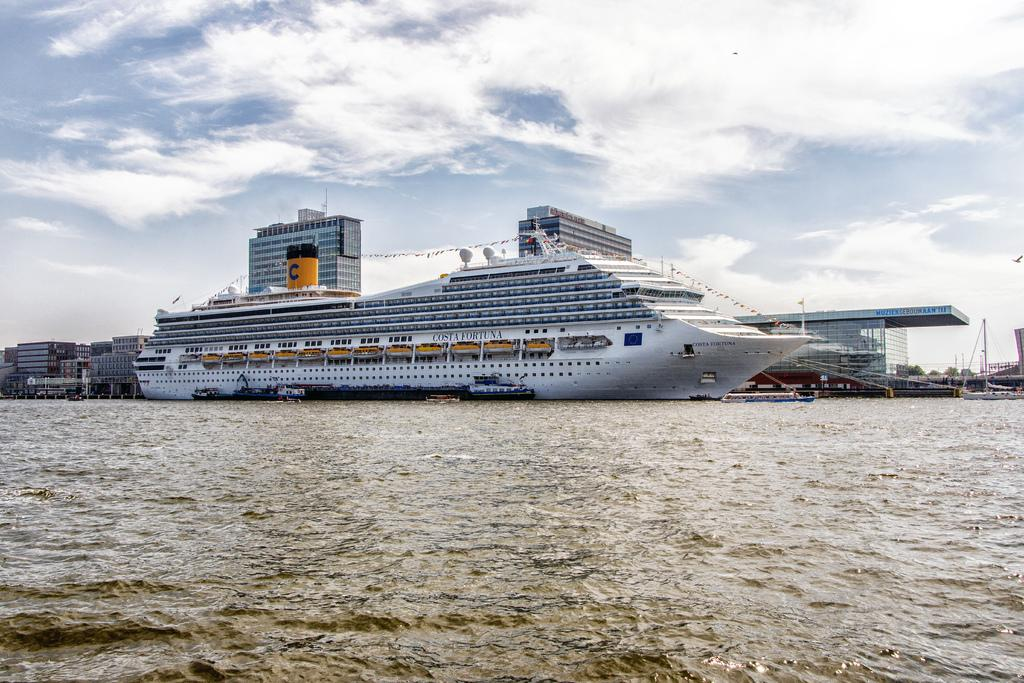What type of vehicle is present in the image? There is a ship in the image. Are there any other similar vehicles in the image? Yes, there are boats in the image. Where are the ship and boats located? The ship and boats are on the water. What can be seen in the background of the image? There are buildings and clouds in the background of the image. What is the name of the amusement park near the ship in the image? There is no amusement park mentioned or visible in the image. 